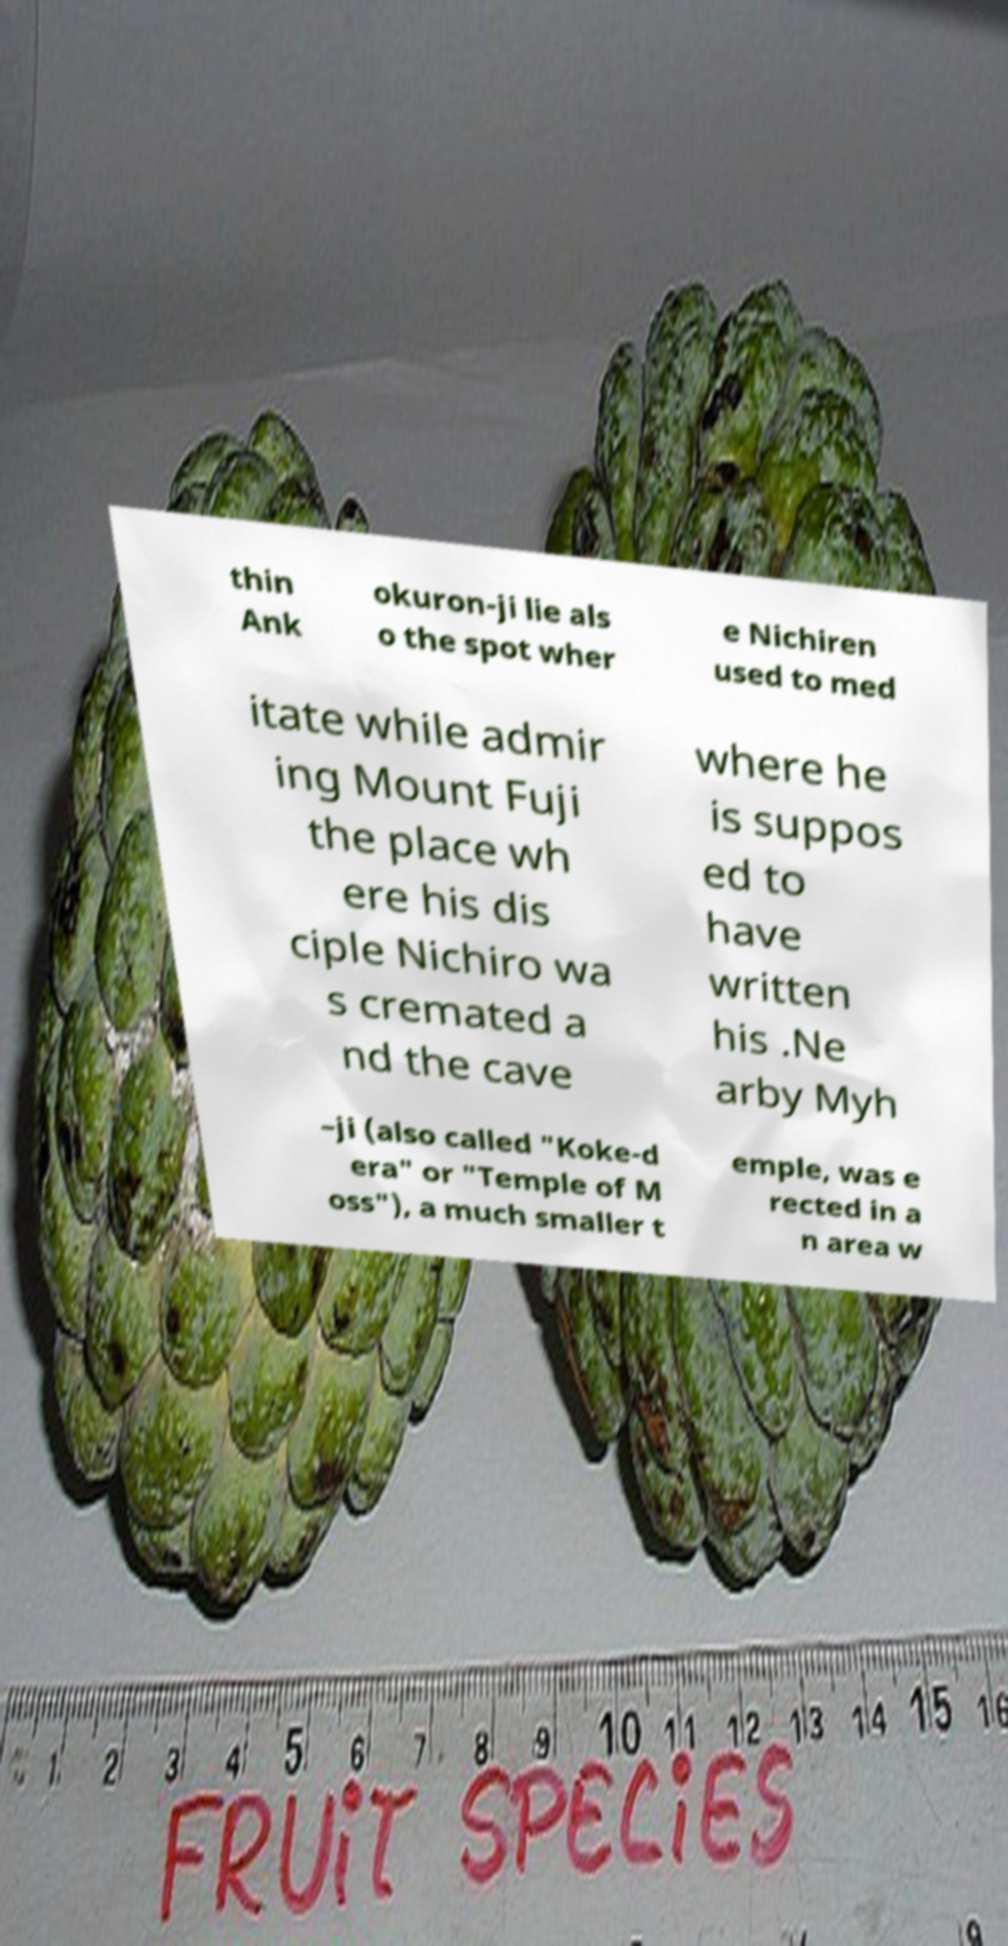For documentation purposes, I need the text within this image transcribed. Could you provide that? thin Ank okuron-ji lie als o the spot wher e Nichiren used to med itate while admir ing Mount Fuji the place wh ere his dis ciple Nichiro wa s cremated a nd the cave where he is suppos ed to have written his .Ne arby Myh –ji (also called "Koke-d era" or "Temple of M oss"), a much smaller t emple, was e rected in a n area w 